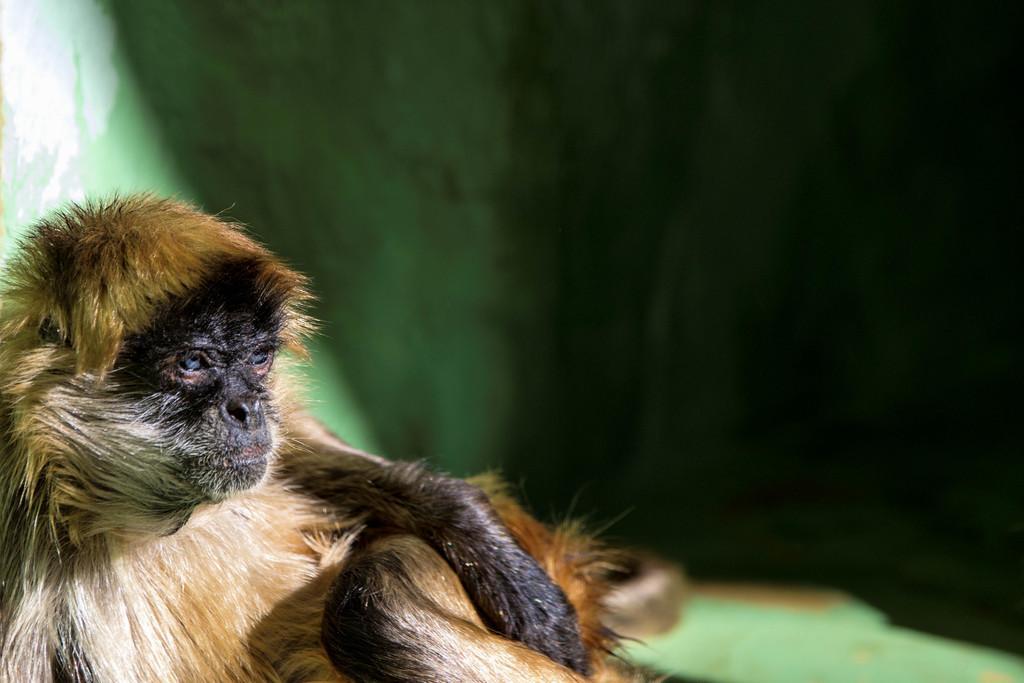Describe this image in one or two sentences. Front portion of the image we can see a monkey. Background it is blur. 